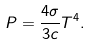<formula> <loc_0><loc_0><loc_500><loc_500>P = \frac { 4 \sigma } { 3 c } T ^ { 4 } .</formula> 